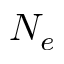<formula> <loc_0><loc_0><loc_500><loc_500>N _ { e }</formula> 